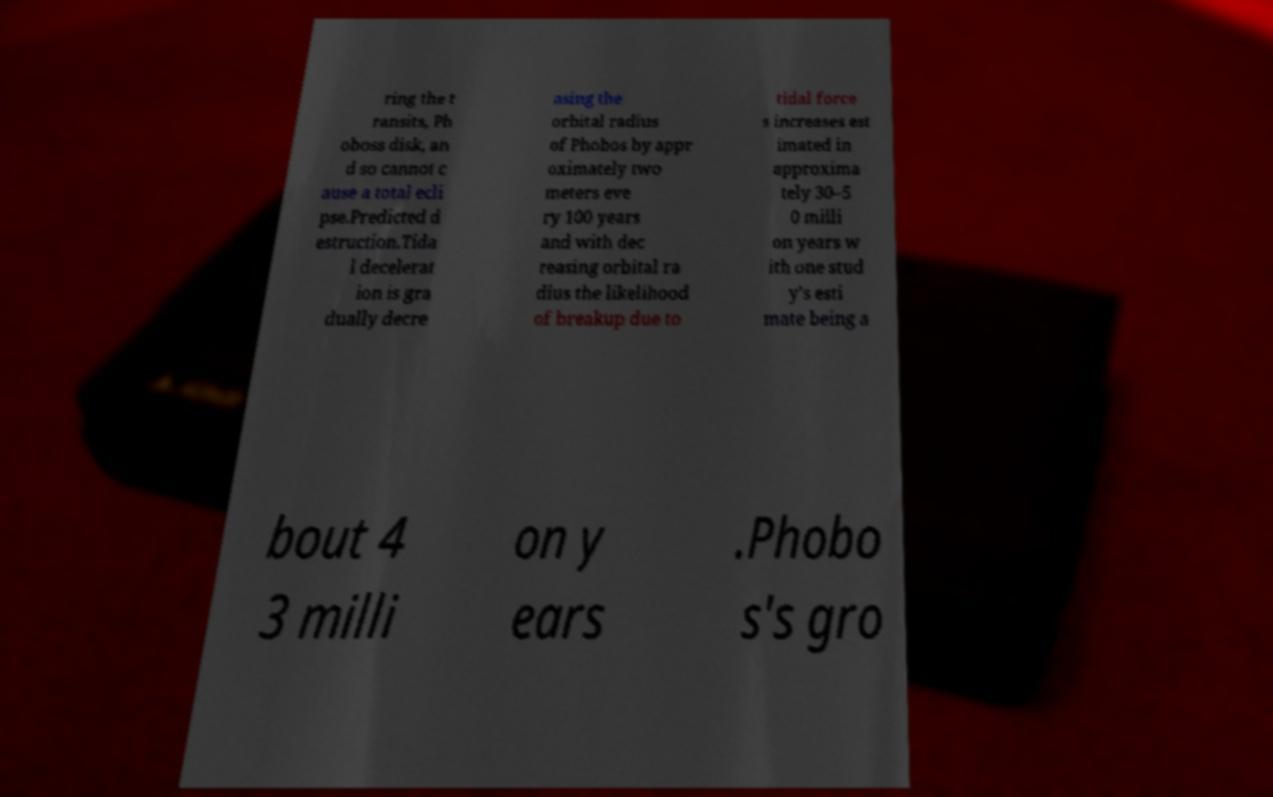Can you read and provide the text displayed in the image?This photo seems to have some interesting text. Can you extract and type it out for me? ring the t ransits, Ph oboss disk, an d so cannot c ause a total ecli pse.Predicted d estruction.Tida l decelerat ion is gra dually decre asing the orbital radius of Phobos by appr oximately two meters eve ry 100 years and with dec reasing orbital ra dius the likelihood of breakup due to tidal force s increases est imated in approxima tely 30–5 0 milli on years w ith one stud y's esti mate being a bout 4 3 milli on y ears .Phobo s's gro 